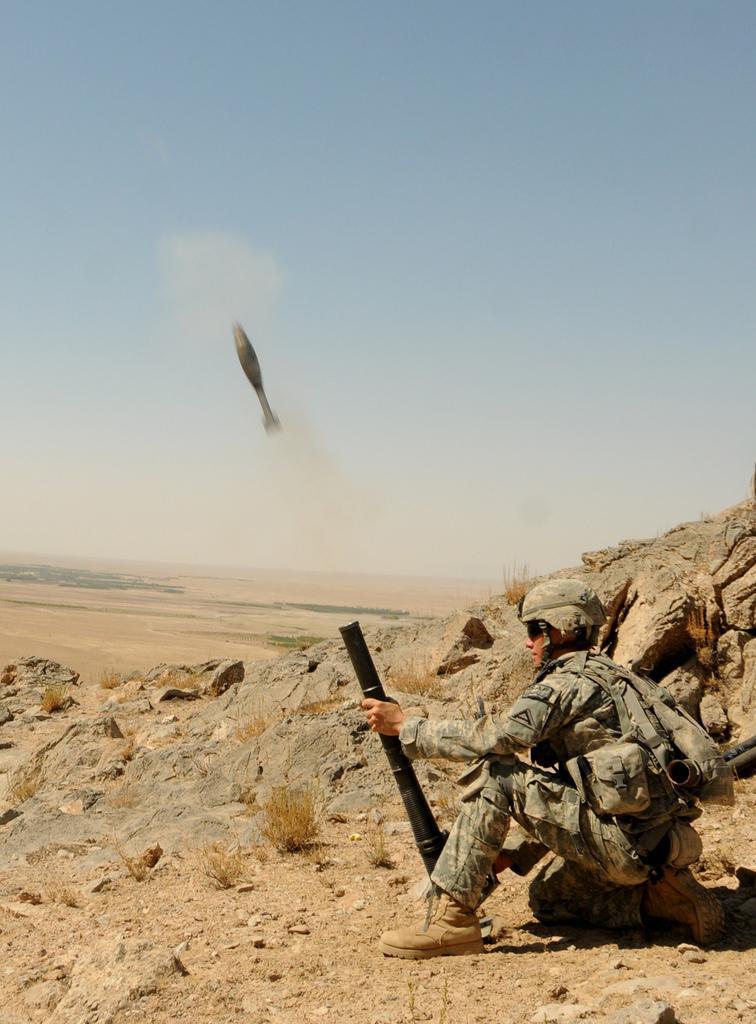How would you summarize this image in a sentence or two? In this image I can see the person sitting and holding some object and the person is wearing the military dress and I can see few stones. In the background I can see some object and the sky is in blue and white color. 